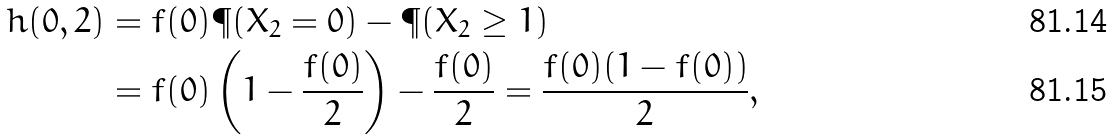<formula> <loc_0><loc_0><loc_500><loc_500>h ( 0 , 2 ) & = f ( 0 ) \P ( X _ { 2 } = 0 ) - \P ( X _ { 2 } \geq 1 ) \\ & = f ( 0 ) \left ( 1 - \frac { f ( 0 ) } { 2 } \right ) - \frac { f ( 0 ) } { 2 } = \frac { f ( 0 ) ( 1 - f ( 0 ) ) } { 2 } ,</formula> 